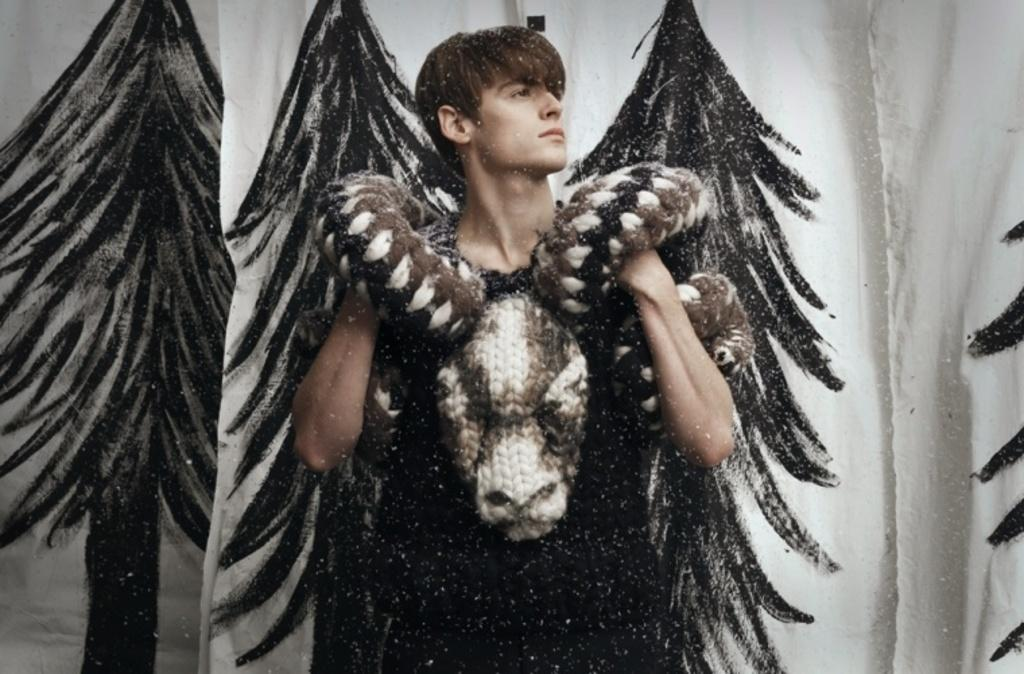What is the main subject of the image? There is a man standing in the image. What is the man wearing in the image? The man is wearing a costume. What can be seen behind the man in the image? There are clothes hanging behind the man. What is the design on the cloth of the hanging clothes? The cloth has a print of trees. What type of needle is being used to sew the beads onto the man's costume in the image? There is no needle or beads present in the image, and therefore no such activity can be observed. 